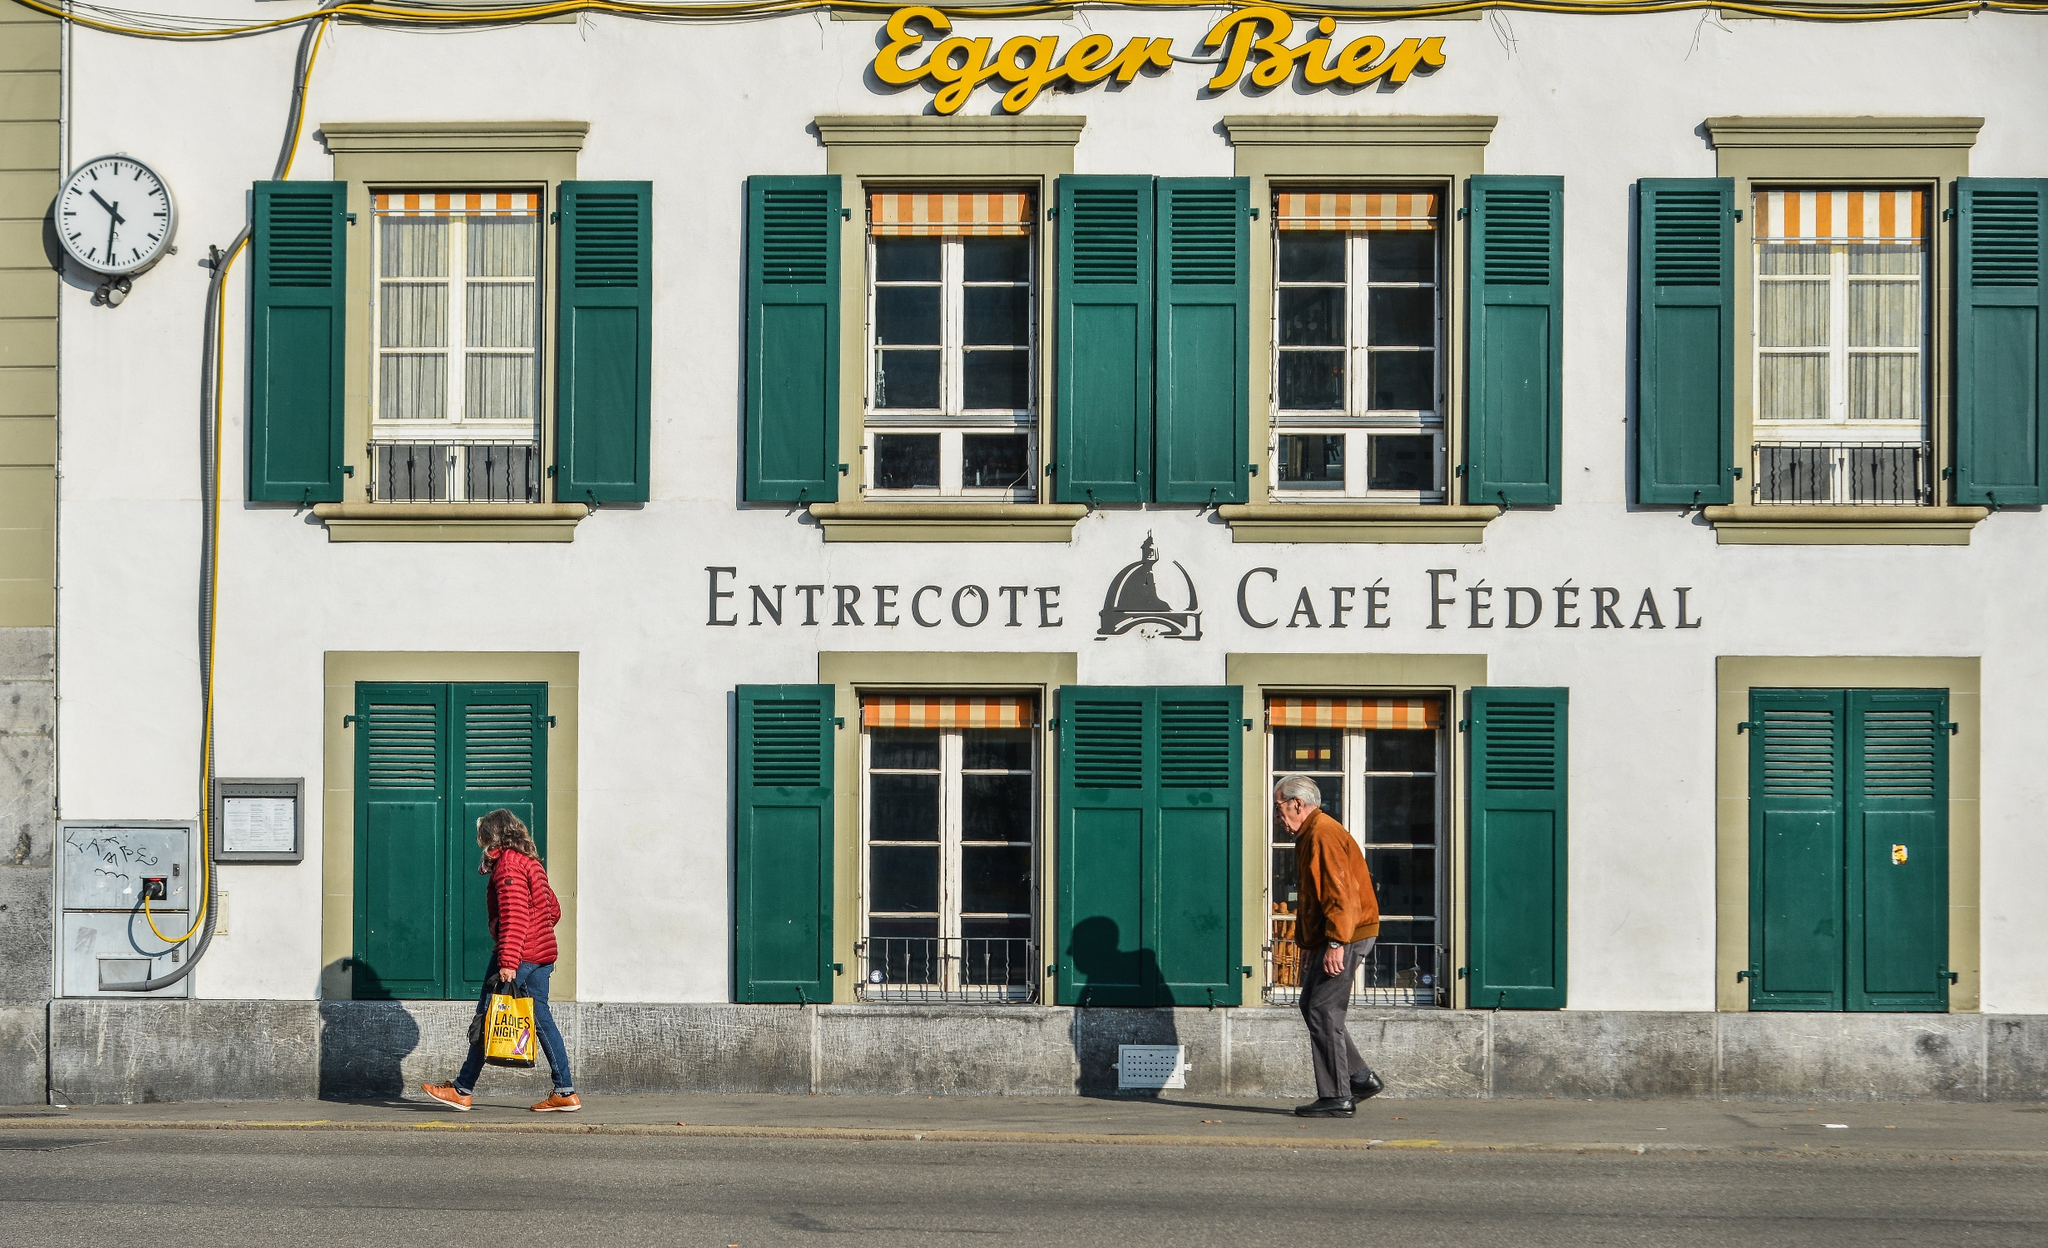What do you think is going on in this snapshot? The image showcases a picturesque day in a quaint Swiss town, capturing the delightful essence of everyday life. The focal point is a charming white building with vibrant green shutters, housing the 'Entrecote Café Fédéral'. The façade is graced by a prominent clock on the left, quietly observing the rhythm of the day. Two individuals are seen mid-stride on the street, adding a sense of movement and liveliness to the serene scene. The bright, clear blue sky casts a warm glow, enhancing the building's crisp white color and the striking green of the shutters, epitomizing a perfect day in Switzerland. 